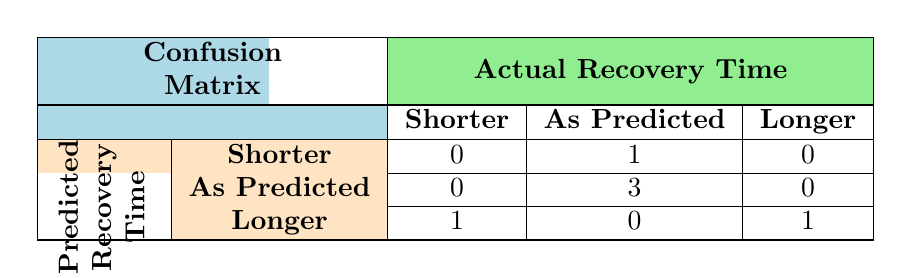What is the total number of injuries classified as “As Predicted”? In the table, we can see the entries under the "As Predicted" category. There are 3 injuries that fall under this classification.
Answer: 3 How many injuries were predicted to take a longer recovery time but actually took less time? In the table, there is one injury classified as “Longer” in predicted recovery time that took less time (Achilles Tendon Injury, predicted 3 months, actual 2 months).
Answer: 1 Did any injuries have a predicted recovery time that was shorter than the actual recovery time? Yes, the Hamstring Strain (predicted 2 weeks, actual 3 weeks) and the Knee Ligament Tear (predicted 6 months, actual 8 months) show a shorter predicted recovery time than the actual.
Answer: Yes What percentage of injuries were accurately predicted in terms of recovery time? To find the percentage, we first identify the total injuries (6) and the accurately predicted ones (Ankle Sprain, Fractured Foot, Concussion – 3). The percentage is (3/6)*100 = 50%.
Answer: 50% Is it true that no injuries were predicted to take a shorter recovery time? Evaluating the table, there is one entry (Hamstring Strain) under shorter where the predicted time was indeed classified as shorter.
Answer: No What is the total count of injuries predicted to take shorter recovery time that matched the actual recovery time? Only the Concussion is the classification under "Shorter" that matched the actual recovery time. Therefore, the total count is 1.
Answer: 1 What is the combined total of injuries with predicted recovery times classified as “Longer”? There are 2 injuries classified under “Longer”: Knee Ligament Tear and Hamstring Strain, summing them gives us a total of 2.
Answer: 2 